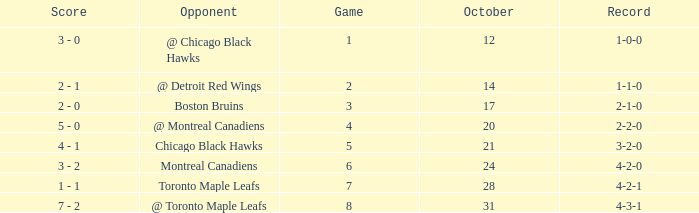Could you parse the entire table? {'header': ['Score', 'Opponent', 'Game', 'October', 'Record'], 'rows': [['3 - 0', '@ Chicago Black Hawks', '1', '12', '1-0-0'], ['2 - 1', '@ Detroit Red Wings', '2', '14', '1-1-0'], ['2 - 0', 'Boston Bruins', '3', '17', '2-1-0'], ['5 - 0', '@ Montreal Canadiens', '4', '20', '2-2-0'], ['4 - 1', 'Chicago Black Hawks', '5', '21', '3-2-0'], ['3 - 2', 'Montreal Canadiens', '6', '24', '4-2-0'], ['1 - 1', 'Toronto Maple Leafs', '7', '28', '4-2-1'], ['7 - 2', '@ Toronto Maple Leafs', '8', '31', '4-3-1']]} What was the score of the game after game 6 on October 28? 1 - 1. 